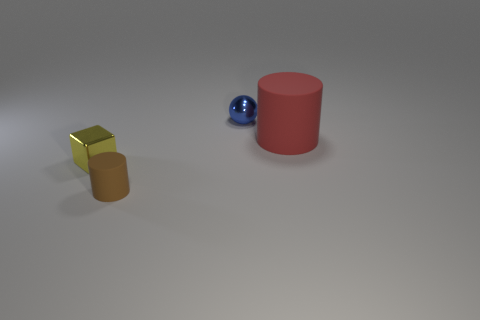The thing that is to the right of the metal ball is what color?
Provide a short and direct response. Red. How big is the rubber object that is left of the cylinder that is right of the blue metallic ball?
Provide a short and direct response. Small. There is a rubber object that is on the right side of the tiny brown matte thing; is its shape the same as the yellow metallic thing?
Offer a terse response. No. What material is the other object that is the same shape as the red matte thing?
Give a very brief answer. Rubber. What number of things are rubber cylinders that are behind the yellow object or shiny things that are on the right side of the cube?
Give a very brief answer. 2. There is a large matte object; is its color the same as the tiny object that is in front of the tiny yellow shiny object?
Your answer should be very brief. No. There is a small yellow object that is made of the same material as the tiny blue sphere; what is its shape?
Your answer should be very brief. Cube. What number of cylinders are there?
Your answer should be compact. 2. How many things are either cylinders that are to the left of the big matte object or brown rubber cylinders?
Make the answer very short. 1. There is a rubber cylinder left of the blue ball; is its color the same as the large object?
Your response must be concise. No. 